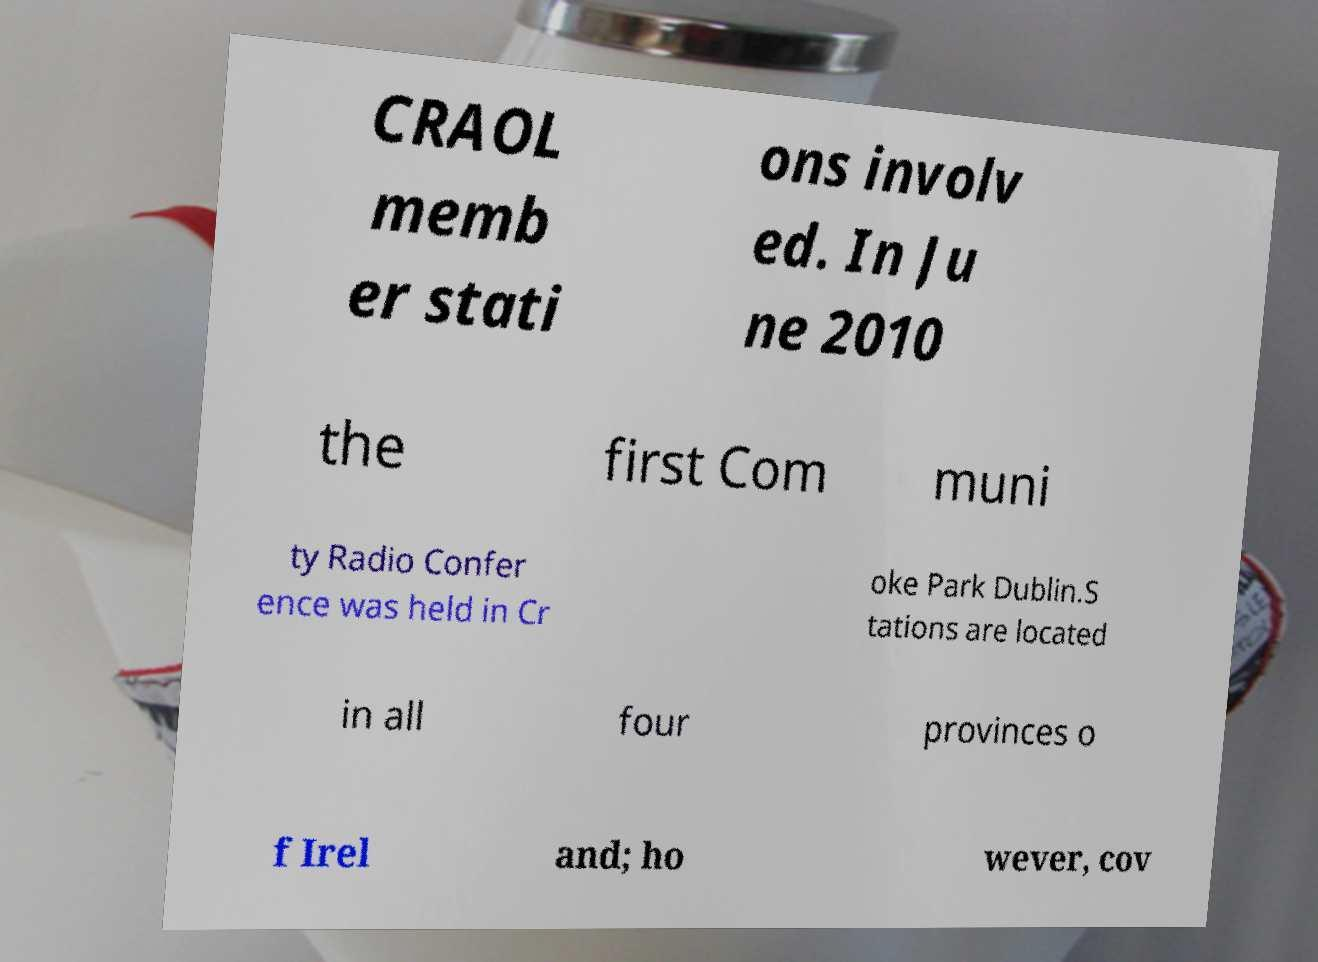Could you extract and type out the text from this image? CRAOL memb er stati ons involv ed. In Ju ne 2010 the first Com muni ty Radio Confer ence was held in Cr oke Park Dublin.S tations are located in all four provinces o f Irel and; ho wever, cov 